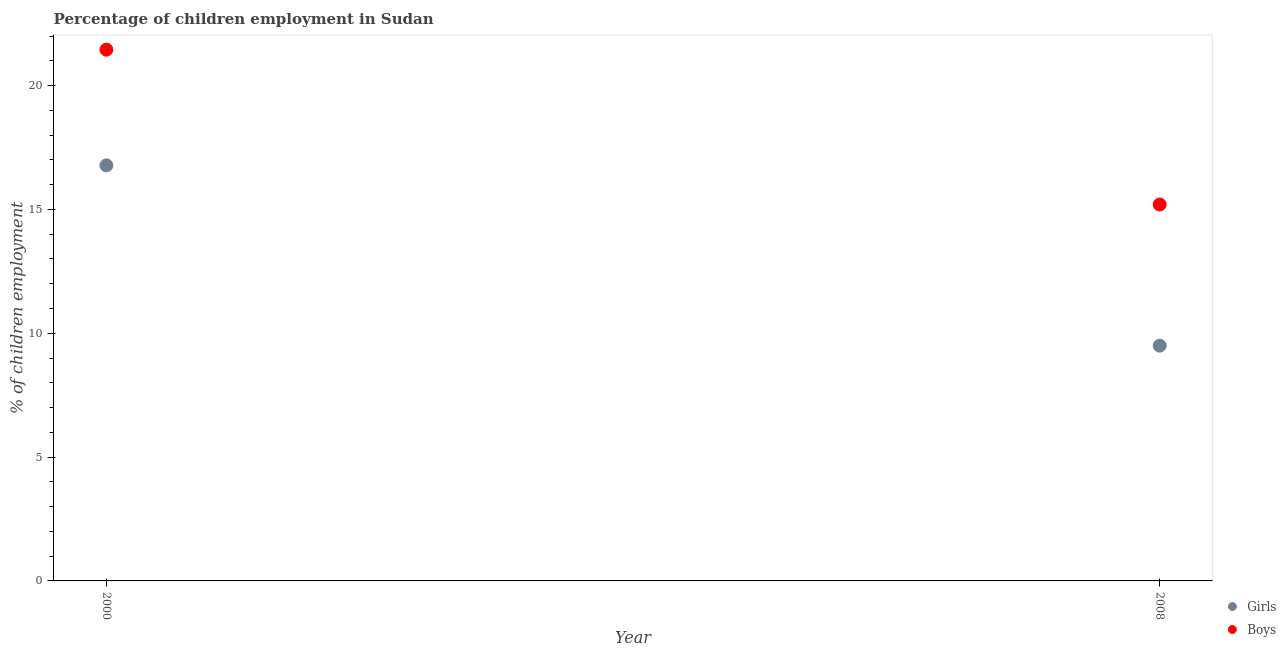What is the percentage of employed boys in 2008?
Provide a short and direct response. 15.2. Across all years, what is the maximum percentage of employed girls?
Provide a short and direct response. 16.78. Across all years, what is the minimum percentage of employed girls?
Provide a short and direct response. 9.5. In which year was the percentage of employed girls minimum?
Offer a terse response. 2008. What is the total percentage of employed boys in the graph?
Your response must be concise. 36.65. What is the difference between the percentage of employed boys in 2000 and that in 2008?
Your answer should be compact. 6.25. What is the difference between the percentage of employed boys in 2000 and the percentage of employed girls in 2008?
Offer a terse response. 11.95. What is the average percentage of employed girls per year?
Give a very brief answer. 13.14. In the year 2000, what is the difference between the percentage of employed girls and percentage of employed boys?
Offer a terse response. -4.67. In how many years, is the percentage of employed girls greater than 10 %?
Ensure brevity in your answer.  1. What is the ratio of the percentage of employed girls in 2000 to that in 2008?
Ensure brevity in your answer.  1.77. In how many years, is the percentage of employed boys greater than the average percentage of employed boys taken over all years?
Offer a very short reply. 1. Does the percentage of employed boys monotonically increase over the years?
Offer a terse response. No. What is the difference between two consecutive major ticks on the Y-axis?
Make the answer very short. 5. Does the graph contain any zero values?
Ensure brevity in your answer.  No. Does the graph contain grids?
Your response must be concise. No. Where does the legend appear in the graph?
Give a very brief answer. Bottom right. What is the title of the graph?
Ensure brevity in your answer.  Percentage of children employment in Sudan. What is the label or title of the Y-axis?
Make the answer very short. % of children employment. What is the % of children employment in Girls in 2000?
Make the answer very short. 16.78. What is the % of children employment in Boys in 2000?
Offer a very short reply. 21.45. Across all years, what is the maximum % of children employment in Girls?
Provide a succinct answer. 16.78. Across all years, what is the maximum % of children employment of Boys?
Your answer should be compact. 21.45. Across all years, what is the minimum % of children employment in Girls?
Offer a very short reply. 9.5. Across all years, what is the minimum % of children employment of Boys?
Make the answer very short. 15.2. What is the total % of children employment in Girls in the graph?
Provide a short and direct response. 26.28. What is the total % of children employment in Boys in the graph?
Offer a very short reply. 36.65. What is the difference between the % of children employment in Girls in 2000 and that in 2008?
Give a very brief answer. 7.28. What is the difference between the % of children employment in Boys in 2000 and that in 2008?
Give a very brief answer. 6.25. What is the difference between the % of children employment of Girls in 2000 and the % of children employment of Boys in 2008?
Offer a very short reply. 1.58. What is the average % of children employment in Girls per year?
Offer a terse response. 13.14. What is the average % of children employment in Boys per year?
Provide a succinct answer. 18.33. In the year 2000, what is the difference between the % of children employment of Girls and % of children employment of Boys?
Your answer should be compact. -4.67. In the year 2008, what is the difference between the % of children employment of Girls and % of children employment of Boys?
Provide a succinct answer. -5.7. What is the ratio of the % of children employment of Girls in 2000 to that in 2008?
Make the answer very short. 1.77. What is the ratio of the % of children employment of Boys in 2000 to that in 2008?
Your answer should be compact. 1.41. What is the difference between the highest and the second highest % of children employment in Girls?
Your answer should be very brief. 7.28. What is the difference between the highest and the second highest % of children employment of Boys?
Offer a very short reply. 6.25. What is the difference between the highest and the lowest % of children employment in Girls?
Offer a very short reply. 7.28. What is the difference between the highest and the lowest % of children employment in Boys?
Offer a terse response. 6.25. 